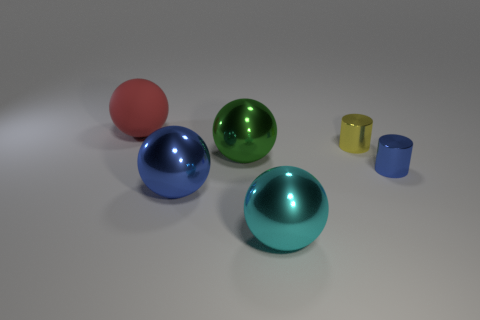Subtract 2 spheres. How many spheres are left? 2 Subtract all big blue shiny balls. How many balls are left? 3 Add 1 large red rubber things. How many objects exist? 7 Subtract all yellow spheres. Subtract all cyan cylinders. How many spheres are left? 4 Subtract all cylinders. How many objects are left? 4 Add 3 small yellow cylinders. How many small yellow cylinders are left? 4 Add 1 shiny cylinders. How many shiny cylinders exist? 3 Subtract 0 cyan cubes. How many objects are left? 6 Subtract all blue metallic cubes. Subtract all large green shiny objects. How many objects are left? 5 